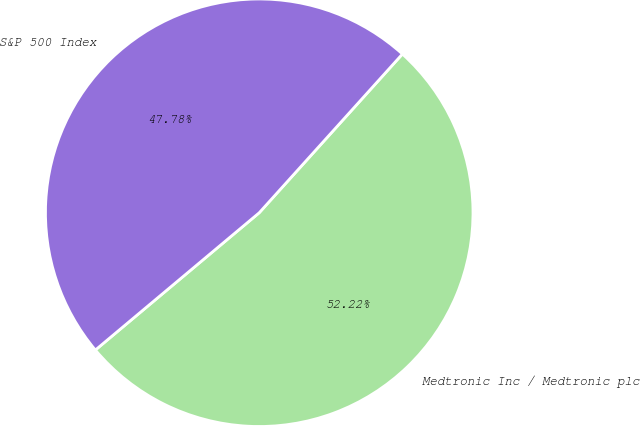<chart> <loc_0><loc_0><loc_500><loc_500><pie_chart><fcel>Medtronic Inc / Medtronic plc<fcel>S&P 500 Index<nl><fcel>52.22%<fcel>47.78%<nl></chart> 